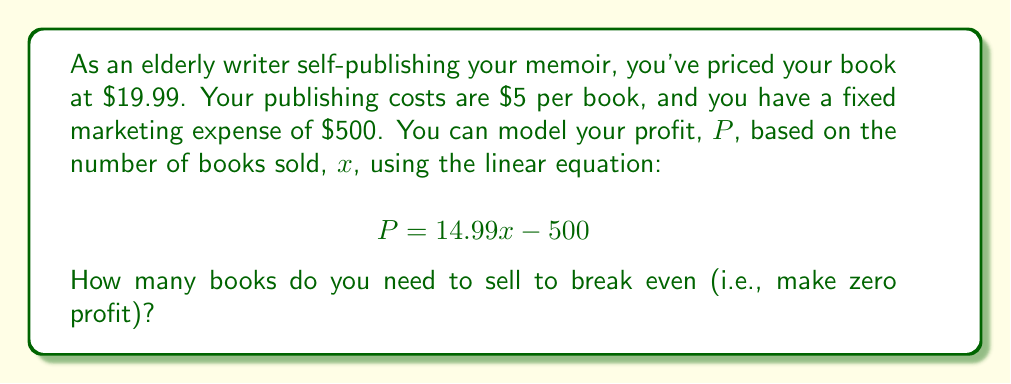Show me your answer to this math problem. To find the break-even point, we need to solve the equation when profit ($P$) equals zero:

$$ 0 = 14.99x - 500 $$

Let's solve this step-by-step:

1. Add 500 to both sides of the equation:
   $$ 500 = 14.99x $$

2. Divide both sides by 14.99:
   $$ \frac{500}{14.99} = x $$

3. Calculate the result:
   $$ x \approx 33.36 $$

Since we can't sell a fraction of a book, we need to round up to the nearest whole number.

Therefore, you need to sell 34 books to break even.

To verify:
$$ P = 14.99 \times 34 - 500 = 509.66 - 500 = 9.66 $$

This shows that selling 34 books will result in a small profit, while selling 33 books would still result in a loss.
Answer: 34 books 